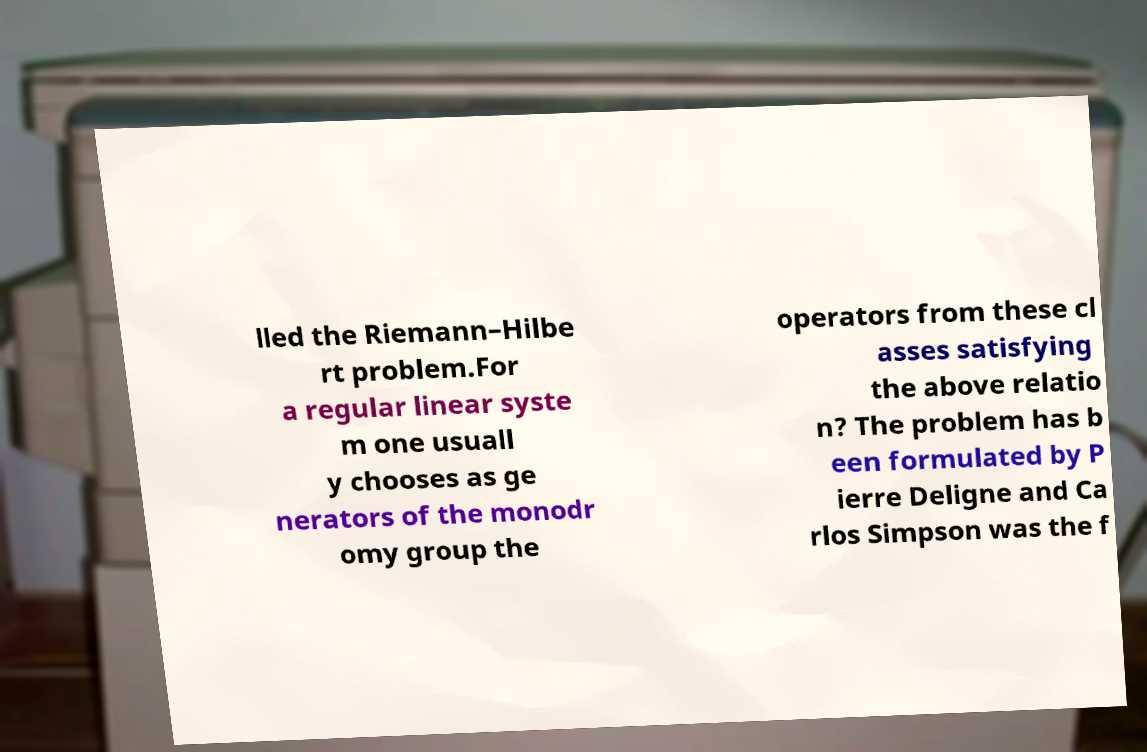Please identify and transcribe the text found in this image. lled the Riemann–Hilbe rt problem.For a regular linear syste m one usuall y chooses as ge nerators of the monodr omy group the operators from these cl asses satisfying the above relatio n? The problem has b een formulated by P ierre Deligne and Ca rlos Simpson was the f 